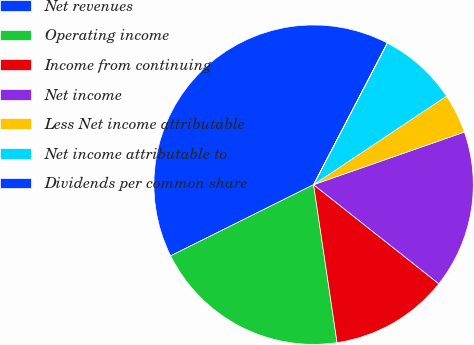<chart> <loc_0><loc_0><loc_500><loc_500><pie_chart><fcel>Net revenues<fcel>Operating income<fcel>Income from continuing<fcel>Net income<fcel>Less Net income attributable<fcel>Net income attributable to<fcel>Dividends per common share<nl><fcel>39.99%<fcel>20.0%<fcel>12.0%<fcel>16.0%<fcel>4.01%<fcel>8.0%<fcel>0.01%<nl></chart> 